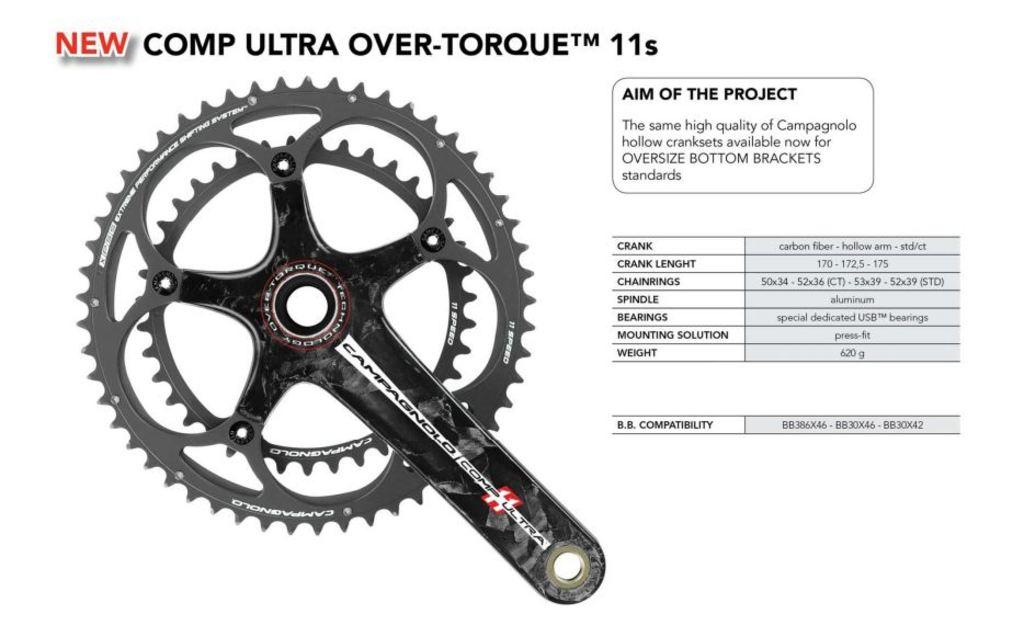What type of object is depicted in the image? The image contains components of a bicycle. Is there any text present in the image? Yes, there is text written on the image. What color is the background of the image? The background of the image is white in color. How many cherries are hanging from the handlebars of the bicycle in the image? There are no cherries present in the image, as it features components of a bicycle and text on a white background. 